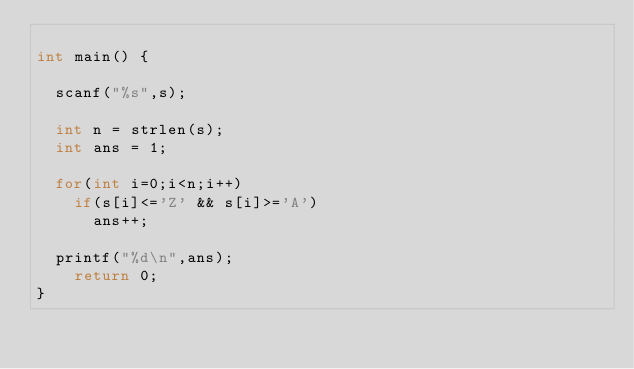<code> <loc_0><loc_0><loc_500><loc_500><_C++_>
int main() {

	scanf("%s",s);

	int n = strlen(s);
	int ans = 1;

	for(int i=0;i<n;i++)
		if(s[i]<='Z' && s[i]>='A')
			ans++;
	
	printf("%d\n",ans);
    return 0;
}
</code> 